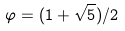Convert formula to latex. <formula><loc_0><loc_0><loc_500><loc_500>\varphi = ( 1 + \sqrt { 5 } ) / 2</formula> 